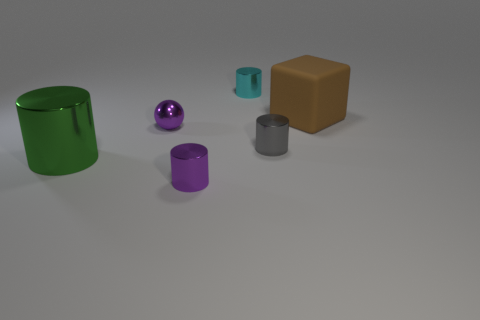Add 2 brown objects. How many objects exist? 8 Subtract all blocks. How many objects are left? 5 Subtract 1 green cylinders. How many objects are left? 5 Subtract all big brown rubber objects. Subtract all cyan shiny objects. How many objects are left? 4 Add 1 small metal balls. How many small metal balls are left? 2 Add 6 red cylinders. How many red cylinders exist? 6 